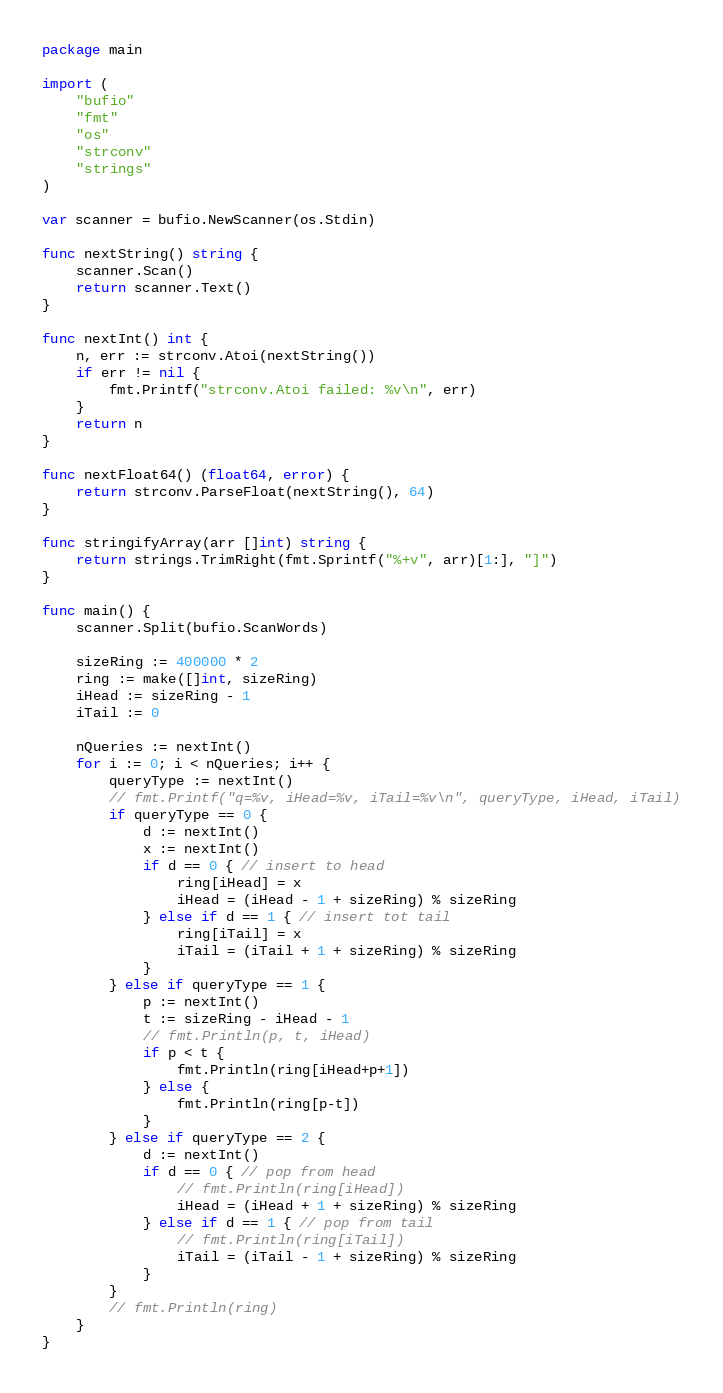Convert code to text. <code><loc_0><loc_0><loc_500><loc_500><_Go_>package main

import (
	"bufio"
	"fmt"
	"os"
	"strconv"
	"strings"
)

var scanner = bufio.NewScanner(os.Stdin)

func nextString() string {
	scanner.Scan()
	return scanner.Text()
}

func nextInt() int {
	n, err := strconv.Atoi(nextString())
	if err != nil {
		fmt.Printf("strconv.Atoi failed: %v\n", err)
	}
	return n
}

func nextFloat64() (float64, error) {
	return strconv.ParseFloat(nextString(), 64)
}

func stringifyArray(arr []int) string {
	return strings.TrimRight(fmt.Sprintf("%+v", arr)[1:], "]")
}

func main() {
	scanner.Split(bufio.ScanWords)

	sizeRing := 400000 * 2
	ring := make([]int, sizeRing)
	iHead := sizeRing - 1
	iTail := 0

	nQueries := nextInt()
	for i := 0; i < nQueries; i++ {
		queryType := nextInt()
		// fmt.Printf("q=%v, iHead=%v, iTail=%v\n", queryType, iHead, iTail)
		if queryType == 0 {
			d := nextInt()
			x := nextInt()
			if d == 0 { // insert to head
				ring[iHead] = x
				iHead = (iHead - 1 + sizeRing) % sizeRing
			} else if d == 1 { // insert tot tail
				ring[iTail] = x
				iTail = (iTail + 1 + sizeRing) % sizeRing
			}
		} else if queryType == 1 {
			p := nextInt()
			t := sizeRing - iHead - 1
			// fmt.Println(p, t, iHead)
			if p < t {
				fmt.Println(ring[iHead+p+1])
			} else {
				fmt.Println(ring[p-t])
			}
		} else if queryType == 2 {
			d := nextInt()
			if d == 0 { // pop from head
				// fmt.Println(ring[iHead])
				iHead = (iHead + 1 + sizeRing) % sizeRing
			} else if d == 1 { // pop from tail
				// fmt.Println(ring[iTail])
				iTail = (iTail - 1 + sizeRing) % sizeRing
			}
		}
		// fmt.Println(ring)
	}
}

</code> 